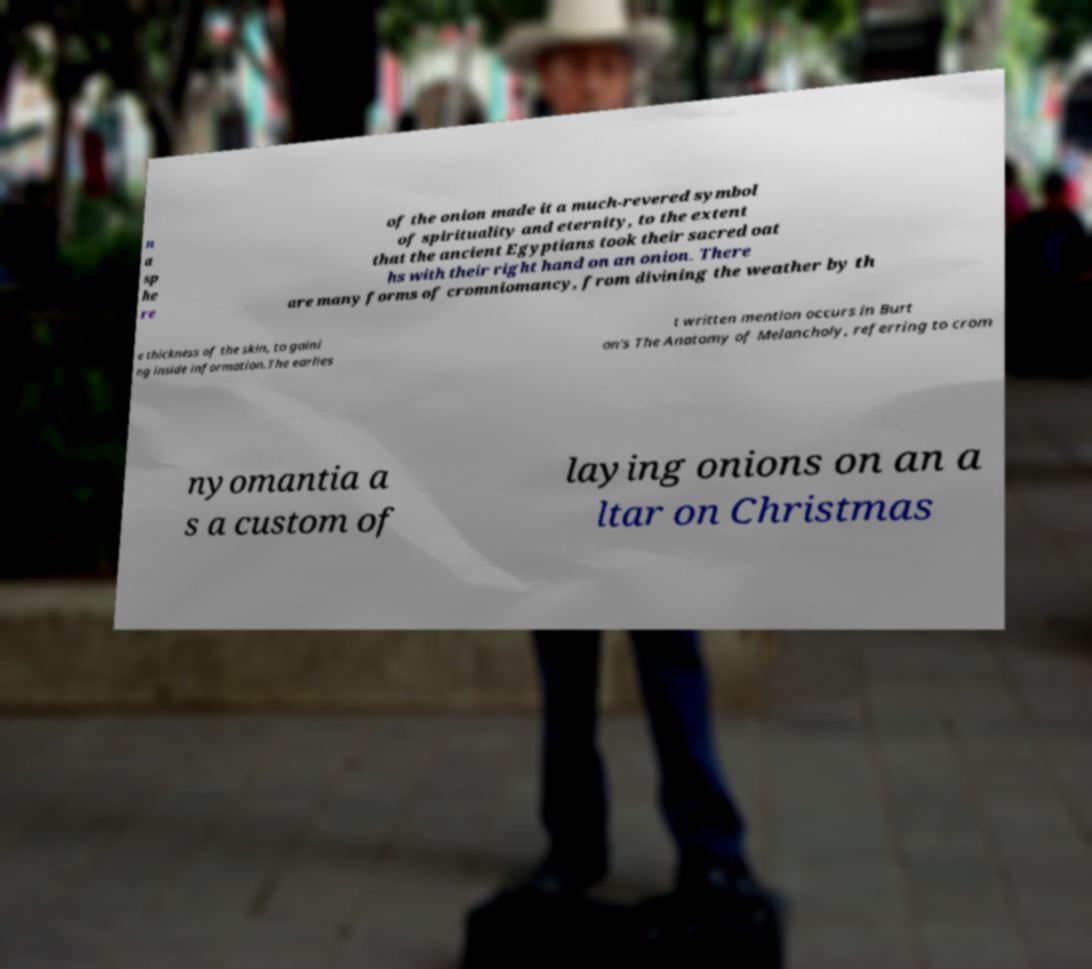Please read and relay the text visible in this image. What does it say? n a sp he re of the onion made it a much-revered symbol of spirituality and eternity, to the extent that the ancient Egyptians took their sacred oat hs with their right hand on an onion. There are many forms of cromniomancy, from divining the weather by th e thickness of the skin, to gaini ng inside information.The earlies t written mention occurs in Burt on's The Anatomy of Melancholy, referring to crom nyomantia a s a custom of laying onions on an a ltar on Christmas 